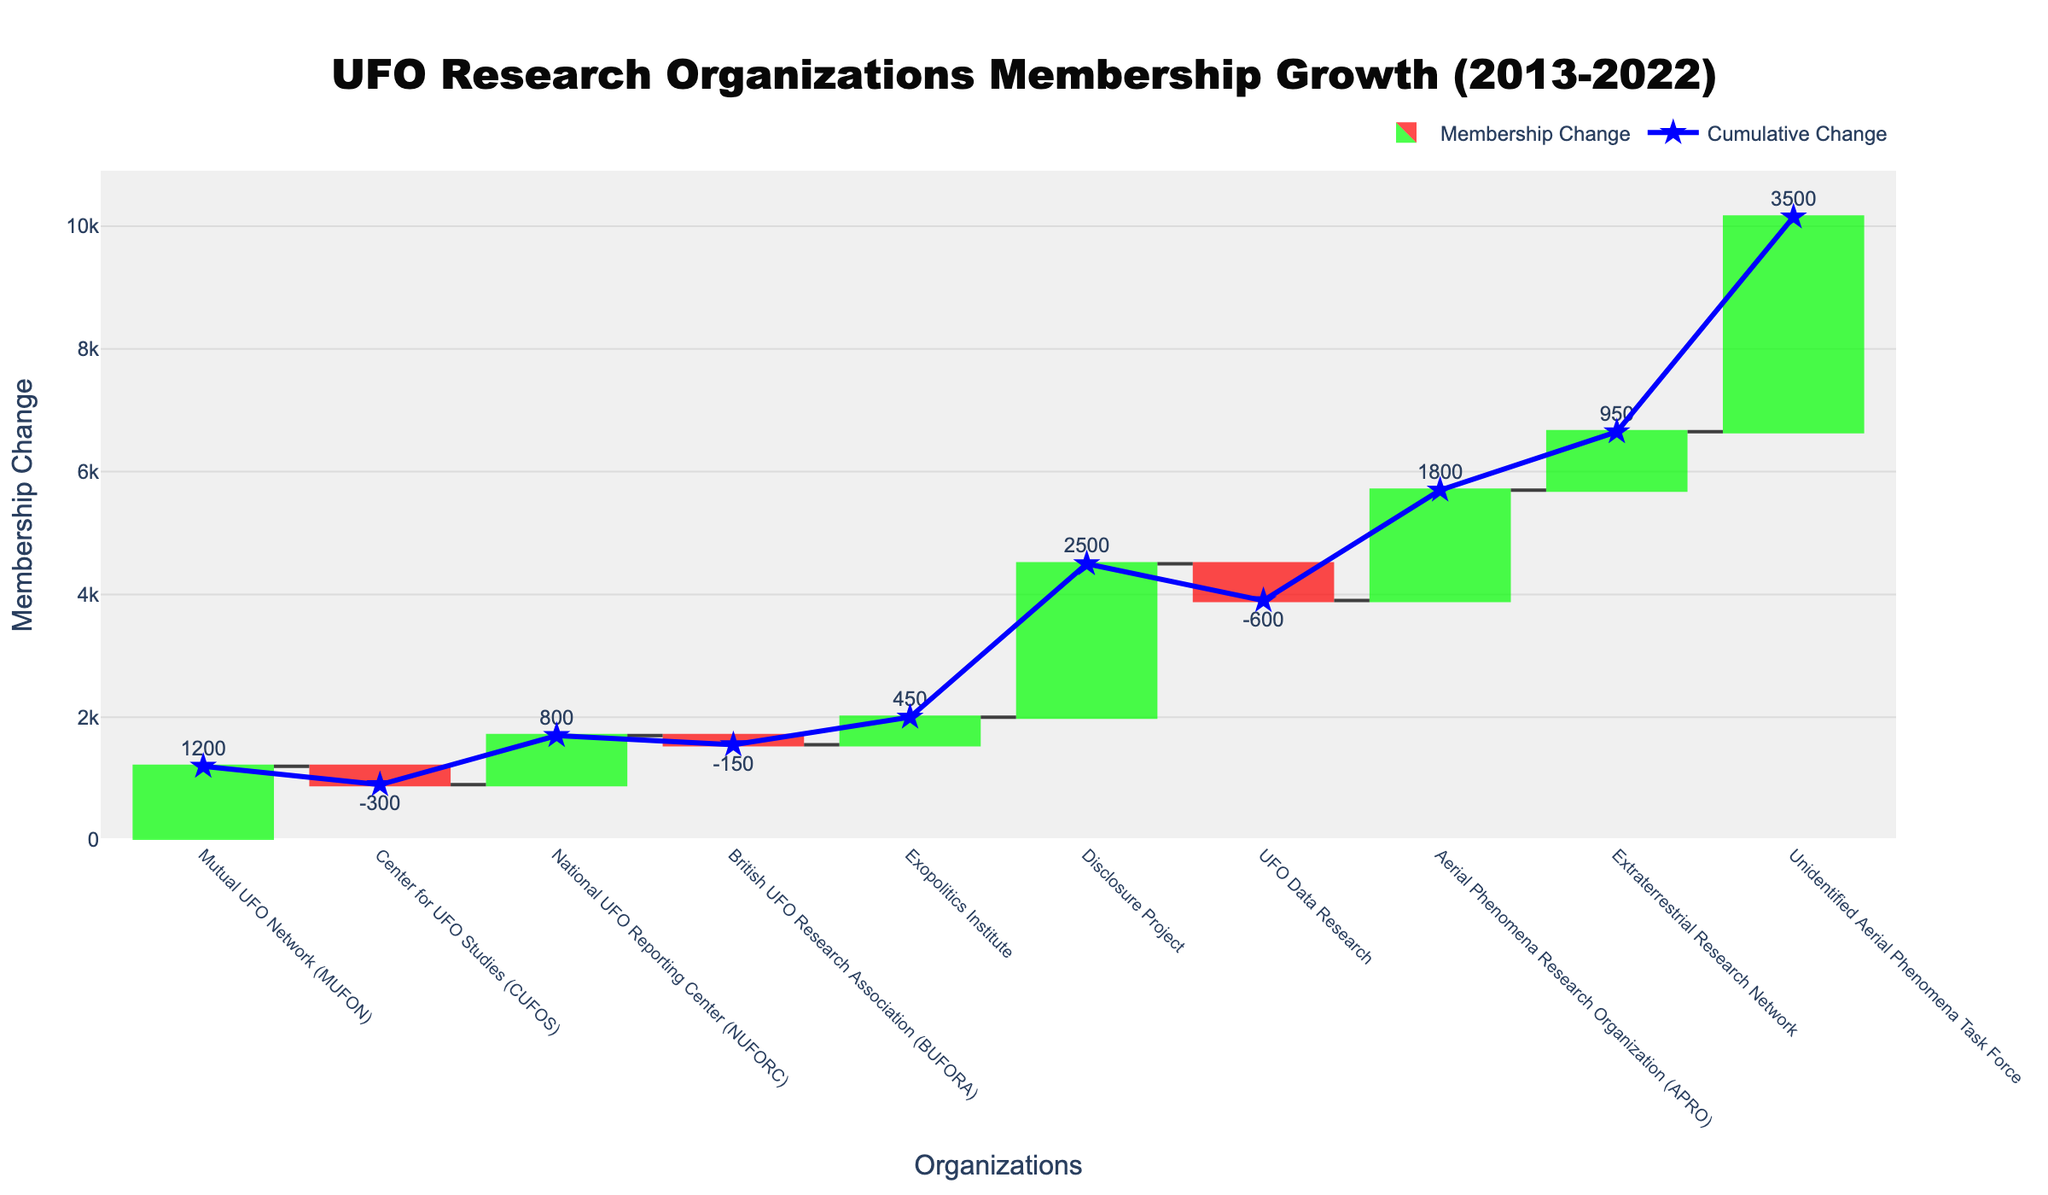What is the title of the chart? The title is displayed prominently at the top of the chart. It is usually designed to provide an overview or main takeaway of the visual. Here, it is spelled out in a larger font at the center top.
Answer: UFO Research Organizations Membership Growth (2013-2022) How many organizations are listed on the chart? The number of organizations can be counted directly along the x-axis at the bottom of the chart. Each bar represents one organization.
Answer: 10 What color represents an increase in membership change? The chart uses different colors to distinguish between increases and decreases. The color for increases is a shade of green.
Answer: Green Which organization had the highest positive membership change in a single year? We look at the bars representing positive changes and find the one that extends the highest upward. This is the bar for the Unidentified Aerial Phenomena Task Force in 2022.
Answer: Unidentified Aerial Phenomena Task Force What is the total cumulative membership change by the end of the period? The cumulative change over the period would be represented by the endpoint of the cumulative change line, which is shown on the vertical axis where the scatter trace ends.
Answer: 8350 What was the membership change for the Center for UFO Studies (CUFOS) in 2014? We locate the CUFOS label on the x-axis and look at the corresponding bar, which shows a negative change. The text shows -300.
Answer: -300 Which organization had a membership decrease in 2019? We identify the bars that extend downward and look for the corresponding organization name. In 2019, this is the UFO Data Research group.
Answer: UFO Data Research What is the difference in membership change between the Disclosure Project in 2018 and the Aerial Phenomena Research Organization (APRO) in 2020? We compare the heights of the bars corresponding to these two organizations. Disclosure Project in 2018 had a change of 2500, and APRO in 2020 had 1800. The difference is 2500 - 1800 = 700.
Answer: 700 If you were to sum the positive and negative membership changes, would the net result be a gain or a loss? All the positive numbers are added, and then all negative numbers are subtracted. Sum of positive changes: 1200 + 800 + 450 + 2500 + 1800 + 950 + 3500 = 11,200. Sum of negative changes: -300 - 150 - 600 = -1050. Net result: 11200 - 1050 = 10150 (gain).
Answer: Gain Which organization contributed the most to the total cumulative membership change in the positive direction? By observing the lengths of all the positive bars, the tallest bar which adds the most towards the top cumulative change would be from Unidentified Aerial Phenomena Task Force.
Answer: Unidentified Aerial Phenomena Task Force 